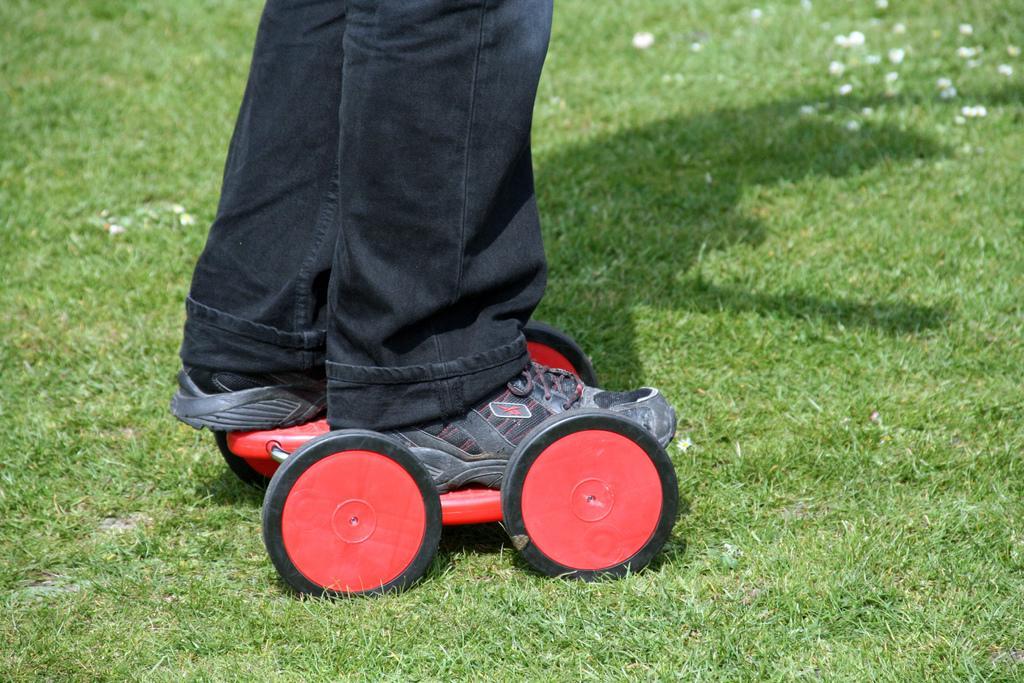Describe this image in one or two sentences. This is a person, these is grass. 